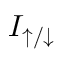Convert formula to latex. <formula><loc_0><loc_0><loc_500><loc_500>I _ { \uparrow / \downarrow }</formula> 